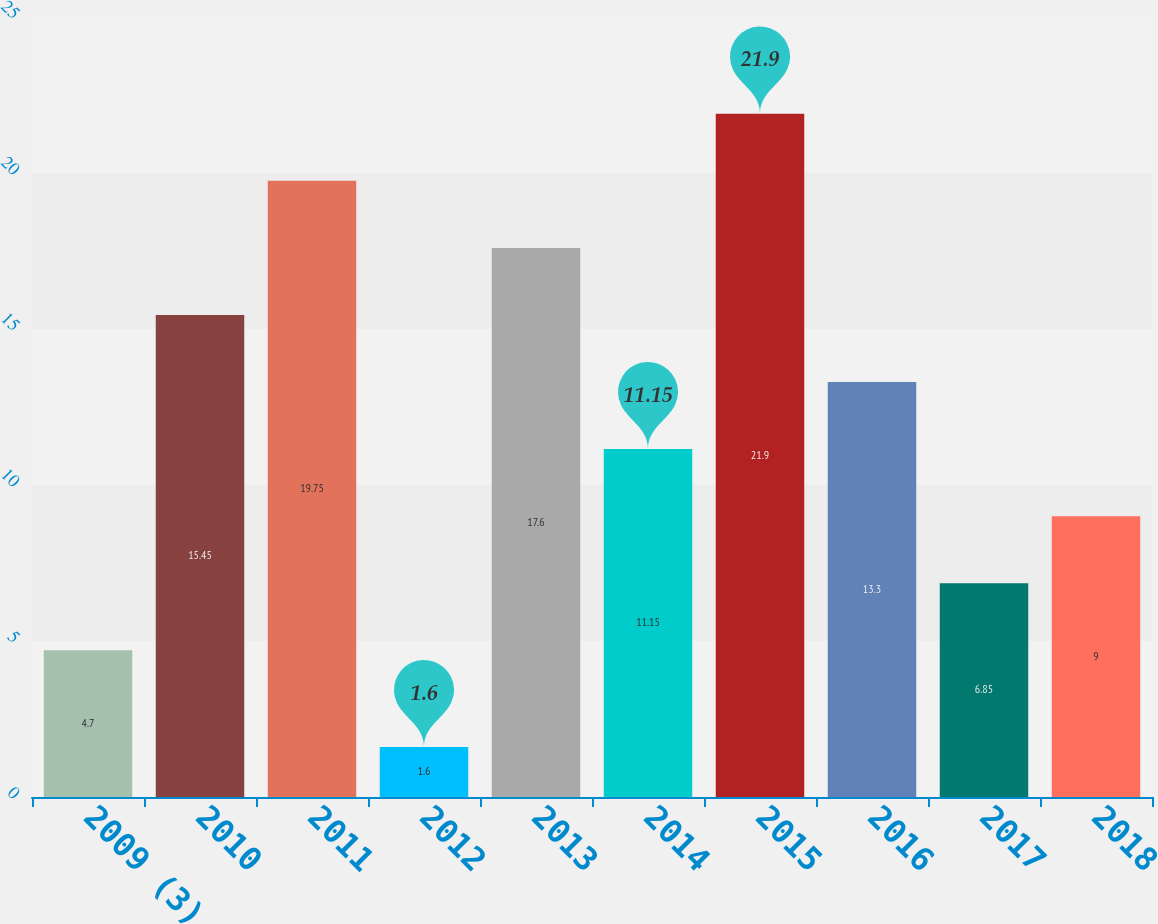<chart> <loc_0><loc_0><loc_500><loc_500><bar_chart><fcel>2009 (3)<fcel>2010<fcel>2011<fcel>2012<fcel>2013<fcel>2014<fcel>2015<fcel>2016<fcel>2017<fcel>2018<nl><fcel>4.7<fcel>15.45<fcel>19.75<fcel>1.6<fcel>17.6<fcel>11.15<fcel>21.9<fcel>13.3<fcel>6.85<fcel>9<nl></chart> 